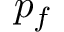<formula> <loc_0><loc_0><loc_500><loc_500>p _ { f }</formula> 